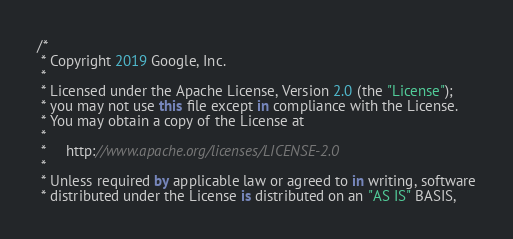<code> <loc_0><loc_0><loc_500><loc_500><_Kotlin_>/*
 * Copyright 2019 Google, Inc.
 *
 * Licensed under the Apache License, Version 2.0 (the "License");
 * you may not use this file except in compliance with the License.
 * You may obtain a copy of the License at
 *
 *     http://www.apache.org/licenses/LICENSE-2.0
 *
 * Unless required by applicable law or agreed to in writing, software
 * distributed under the License is distributed on an "AS IS" BASIS,</code> 